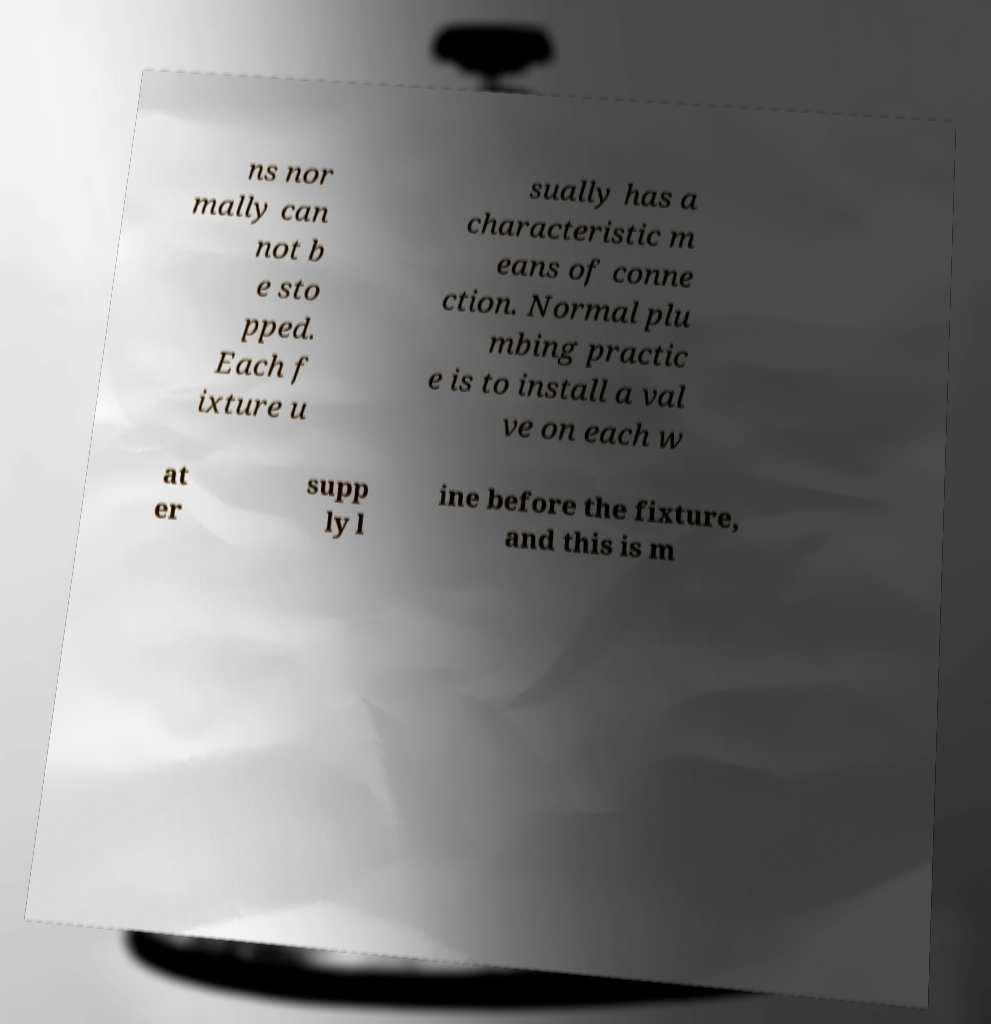For documentation purposes, I need the text within this image transcribed. Could you provide that? ns nor mally can not b e sto pped. Each f ixture u sually has a characteristic m eans of conne ction. Normal plu mbing practic e is to install a val ve on each w at er supp ly l ine before the fixture, and this is m 